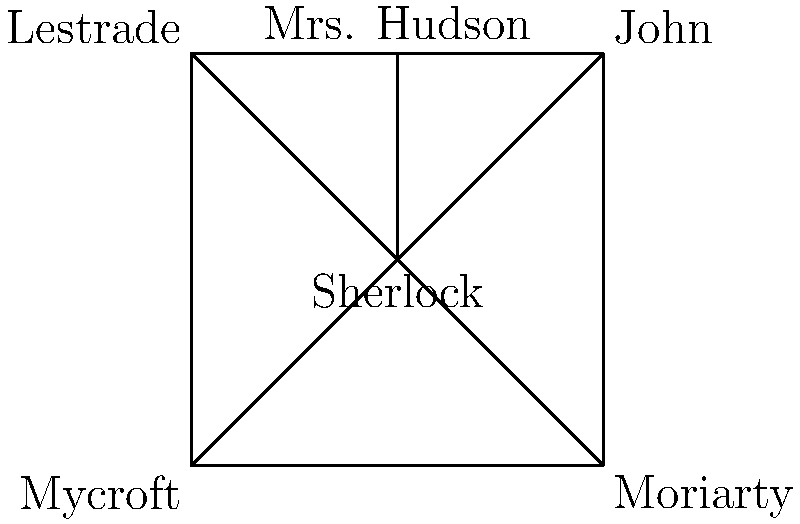In the popular British TV show "Sherlock," which character has the highest degree centrality (most connections) in this simplified network of relationships? To determine the character with the highest degree centrality, we need to count the number of connections (edges) each character has in the network:

1. Sherlock: Connected to John, Mrs. Hudson, Lestrade, Mycroft, and Moriarty (5 connections)
2. John: Connected to Sherlock, Mrs. Hudson, and Moriarty (3 connections)
3. Mrs. Hudson: Connected to Sherlock, John, and Lestrade (3 connections)
4. Lestrade: Connected to Sherlock, Mrs. Hudson, and Mycroft (3 connections)
5. Mycroft: Connected to Sherlock and Lestrade (2 connections)
6. Moriarty: Connected to Sherlock and John (2 connections)

By counting the connections, we can see that Sherlock has the highest number of connections (5), making him the character with the highest degree centrality in this simplified network.
Answer: Sherlock 